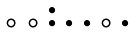<formula> <loc_0><loc_0><loc_500><loc_500>\begin{smallmatrix} & & \bullet \\ \circ & \circ & \bullet & \bullet & \bullet & \circ & \bullet & \\ \end{smallmatrix}</formula> 